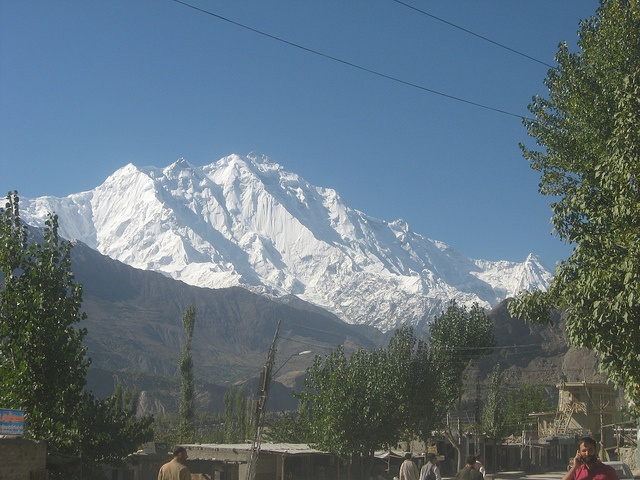Describe the objects in this image and their specific colors. I can see people in gray, maroon, black, and brown tones, people in gray, black, and tan tones, people in gray and black tones, people in gray, black, and darkgray tones, and people in gray, darkgray, and black tones in this image. 